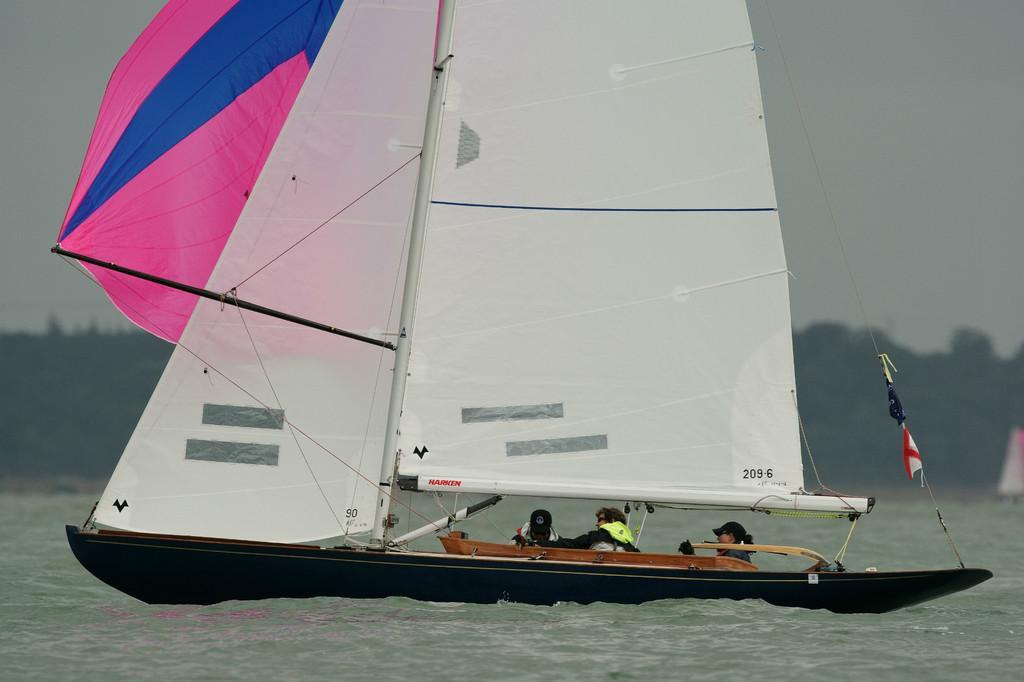Describe this image in one or two sentences. Here in this picture we can see a group of people sailing in a boat which is present in the water over there and we can see they are wearing life jackets on them. 